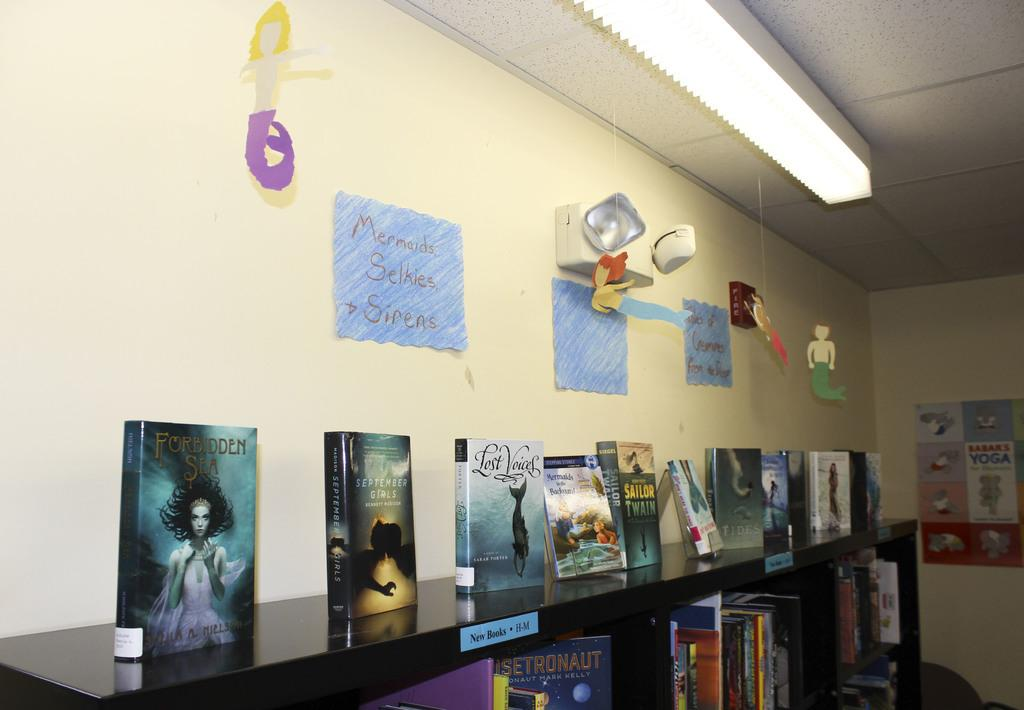What type of items can be seen in the image? There are books in racks, posters on the wall, and paper crafts in the image. What can be found on the wall in the image? There are posters on the wall in the image. What type of crafts are visible in the image? There are paper crafts in the image. What is the source of light visible in the image? There is a light visible at the top of the image. Can you tell me how many plants are growing on the floor in the image? There are no plants visible on the floor in the image. What type of trail can be seen in the image? There is no trail present in the image. 